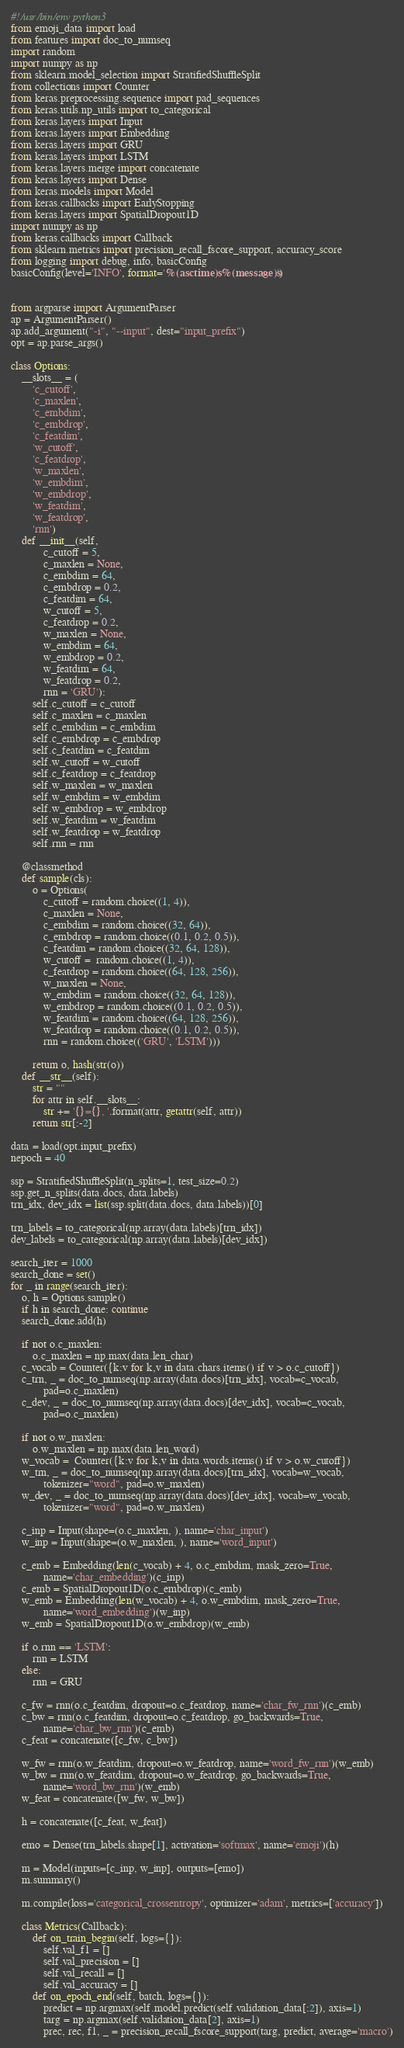Convert code to text. <code><loc_0><loc_0><loc_500><loc_500><_Python_>#!/usr/bin/env python3
from emoji_data import load
from features import doc_to_numseq
import random
import numpy as np
from sklearn.model_selection import StratifiedShuffleSplit
from collections import Counter
from keras.preprocessing.sequence import pad_sequences
from keras.utils.np_utils import to_categorical
from keras.layers import Input
from keras.layers import Embedding
from keras.layers import GRU
from keras.layers import LSTM
from keras.layers.merge import concatenate
from keras.layers import Dense
from keras.models import Model
from keras.callbacks import EarlyStopping
from keras.layers import SpatialDropout1D
import numpy as np
from keras.callbacks import Callback
from sklearn.metrics import precision_recall_fscore_support, accuracy_score
from logging import debug, info, basicConfig
basicConfig(level='INFO', format='%(asctime)s %(message)s')


from argparse import ArgumentParser
ap = ArgumentParser()
ap.add_argument("-i", "--input", dest="input_prefix")
opt = ap.parse_args()

class Options:
    __slots__ = (
        'c_cutoff',
        'c_maxlen',
        'c_embdim',
        'c_embdrop',
        'c_featdim',
        'w_cutoff',
        'c_featdrop',
        'w_maxlen',
        'w_embdim',
        'w_embdrop',
        'w_featdim',
        'w_featdrop',
        'rnn')
    def __init__(self,
            c_cutoff = 5,
            c_maxlen = None,
            c_embdim = 64,
            c_embdrop = 0.2,
            c_featdim = 64,
            w_cutoff = 5,
            c_featdrop = 0.2,
            w_maxlen = None,
            w_embdim = 64,
            w_embdrop = 0.2,
            w_featdim = 64,
            w_featdrop = 0.2,
            rnn = 'GRU'):
        self.c_cutoff = c_cutoff
        self.c_maxlen = c_maxlen
        self.c_embdim = c_embdim
        self.c_embdrop = c_embdrop
        self.c_featdim = c_featdim
        self.w_cutoff = w_cutoff
        self.c_featdrop = c_featdrop
        self.w_maxlen = w_maxlen
        self.w_embdim = w_embdim
        self.w_embdrop = w_embdrop
        self.w_featdim = w_featdim 
        self.w_featdrop = w_featdrop 
        self.rnn = rnn  

    @classmethod
    def sample(cls):
        o = Options(
            c_cutoff = random.choice((1, 4)),
            c_maxlen = None,
            c_embdim = random.choice((32, 64)),
            c_embdrop = random.choice((0.1, 0.2, 0.5)),
            c_featdim = random.choice((32, 64, 128)),
            w_cutoff =  random.choice((1, 4)),
            c_featdrop = random.choice((64, 128, 256)),
            w_maxlen = None,
            w_embdim = random.choice((32, 64, 128)),
            w_embdrop = random.choice((0.1, 0.2, 0.5)),
            w_featdim = random.choice((64, 128, 256)),
            w_featdrop = random.choice((0.1, 0.2, 0.5)),
            rnn = random.choice(('GRU', 'LSTM')))
        
        return o, hash(str(o))
    def __str__(self):
        str = ""
        for attr in self.__slots__:
            str += '{}={}, '.format(attr, getattr(self, attr))
        return str[:-2]

data = load(opt.input_prefix)
nepoch = 40

ssp = StratifiedShuffleSplit(n_splits=1, test_size=0.2)
ssp.get_n_splits(data.docs, data.labels)
trn_idx, dev_idx = list(ssp.split(data.docs, data.labels))[0]

trn_labels = to_categorical(np.array(data.labels)[trn_idx])
dev_labels = to_categorical(np.array(data.labels)[dev_idx])

search_iter = 1000
search_done = set()
for _ in range(search_iter):
    o, h = Options.sample()
    if h in search_done: continue
    search_done.add(h)

    if not o.c_maxlen:
        o.c_maxlen = np.max(data.len_char)
    c_vocab = Counter({k:v for k,v in data.chars.items() if v > o.c_cutoff})
    c_trn, _ = doc_to_numseq(np.array(data.docs)[trn_idx], vocab=c_vocab,
            pad=o.c_maxlen)
    c_dev, _ = doc_to_numseq(np.array(data.docs)[dev_idx], vocab=c_vocab,
            pad=o.c_maxlen)

    if not o.w_maxlen:
        o.w_maxlen = np.max(data.len_word)
    w_vocab =  Counter({k:v for k,v in data.words.items() if v > o.w_cutoff})
    w_trn, _ = doc_to_numseq(np.array(data.docs)[trn_idx], vocab=w_vocab,
            tokenizer="word", pad=o.w_maxlen)
    w_dev, _ = doc_to_numseq(np.array(data.docs)[dev_idx], vocab=w_vocab,
            tokenizer="word", pad=o.w_maxlen)

    c_inp = Input(shape=(o.c_maxlen, ), name='char_input')
    w_inp = Input(shape=(o.w_maxlen, ), name='word_input')

    c_emb = Embedding(len(c_vocab) + 4, o.c_embdim, mask_zero=True,
            name='char_embedding')(c_inp)
    c_emb = SpatialDropout1D(o.c_embdrop)(c_emb)
    w_emb = Embedding(len(w_vocab) + 4, o.w_embdim, mask_zero=True,
            name='word_embedding')(w_inp)
    w_emb = SpatialDropout1D(o.w_embdrop)(w_emb)

    if o.rnn == 'LSTM':
        rnn = LSTM
    else:
        rnn = GRU

    c_fw = rnn(o.c_featdim, dropout=o.c_featdrop, name='char_fw_rnn')(c_emb)
    c_bw = rnn(o.c_featdim, dropout=o.c_featdrop, go_backwards=True,
            name='char_bw_rnn')(c_emb)
    c_feat = concatenate([c_fw, c_bw])

    w_fw = rnn(o.w_featdim, dropout=o.w_featdrop, name='word_fw_rnn')(w_emb)
    w_bw = rnn(o.w_featdim, dropout=o.w_featdrop, go_backwards=True,
            name='word_bw_rnn')(w_emb)
    w_feat = concatenate([w_fw, w_bw])

    h = concatenate([c_feat, w_feat])

    emo = Dense(trn_labels.shape[1], activation='softmax', name='emoji')(h)

    m = Model(inputs=[c_inp, w_inp], outputs=[emo])
    m.summary()

    m.compile(loss='categorical_crossentropy', optimizer='adam', metrics=['accuracy'])

    class Metrics(Callback):
        def on_train_begin(self, logs={}):
            self.val_f1 = []
            self.val_precision = []
            self.val_recall = []
            self.val_accuracy = []
        def on_epoch_end(self, batch, logs={}):
            predict = np.argmax(self.model.predict(self.validation_data[:2]), axis=1)
            targ = np.argmax(self.validation_data[2], axis=1)
            prec, rec, f1, _ = precision_recall_fscore_support(targ, predict, average='macro')</code> 